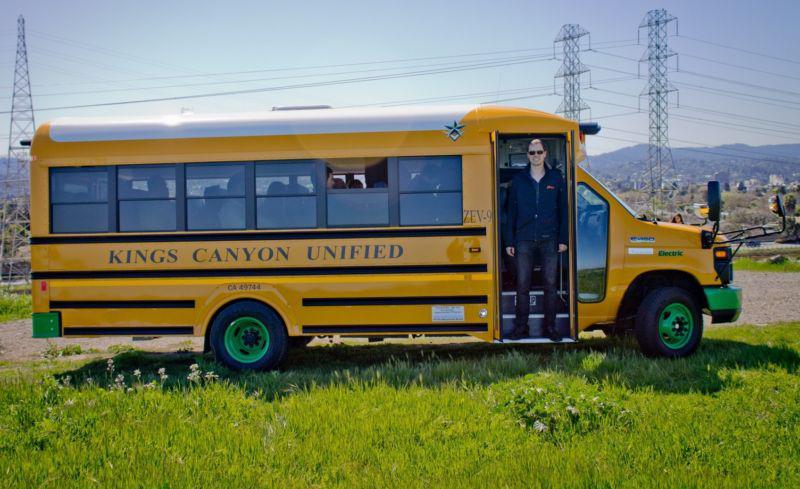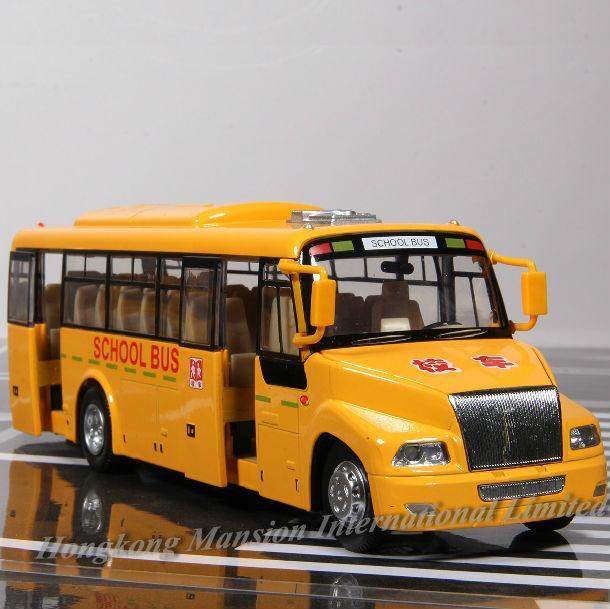The first image is the image on the left, the second image is the image on the right. Assess this claim about the two images: "The left image shows a classic-car-look short bus with three passenger windows on a side, a rounded top, and a scooped hood.". Correct or not? Answer yes or no. No. The first image is the image on the left, the second image is the image on the right. Assess this claim about the two images: "The school bus on the left has the hood of a classic car, not of a school bus.". Correct or not? Answer yes or no. No. 